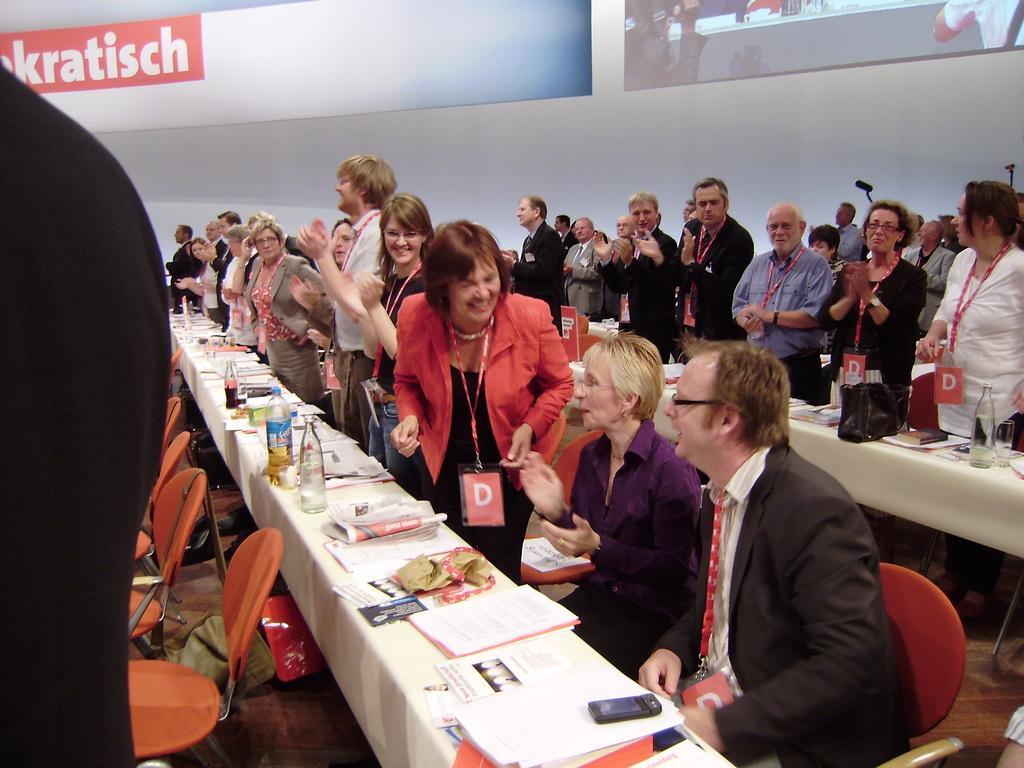Please provide a concise description of this image. In this image there are group of persons standing and sitting and there are tables and on the tables there are bottles, papers and there is a glass and there are empty chairs. In the background there is a screen and on the screen there is a text which is visible. In the front on the left side there is an object which is black in colour. 